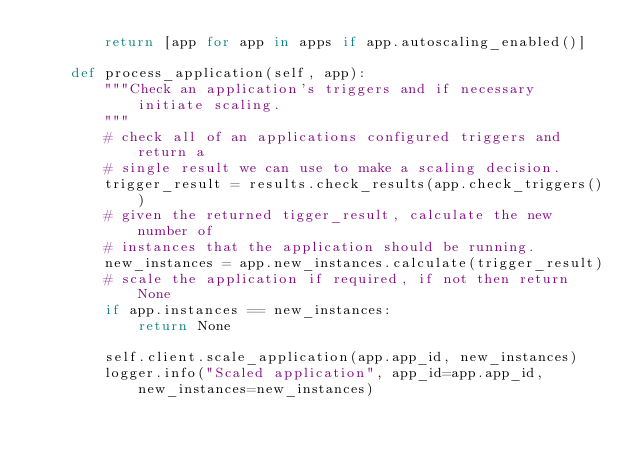Convert code to text. <code><loc_0><loc_0><loc_500><loc_500><_Python_>        return [app for app in apps if app.autoscaling_enabled()]

    def process_application(self, app):
        """Check an application's triggers and if necessary initiate scaling.
        """
        # check all of an applications configured triggers and return a
        # single result we can use to make a scaling decision.
        trigger_result = results.check_results(app.check_triggers())
        # given the returned tigger_result, calculate the new number of
        # instances that the application should be running.
        new_instances = app.new_instances.calculate(trigger_result)
        # scale the application if required, if not then return None
        if app.instances == new_instances:
            return None

        self.client.scale_application(app.app_id, new_instances)
        logger.info("Scaled application", app_id=app.app_id, new_instances=new_instances)
</code> 